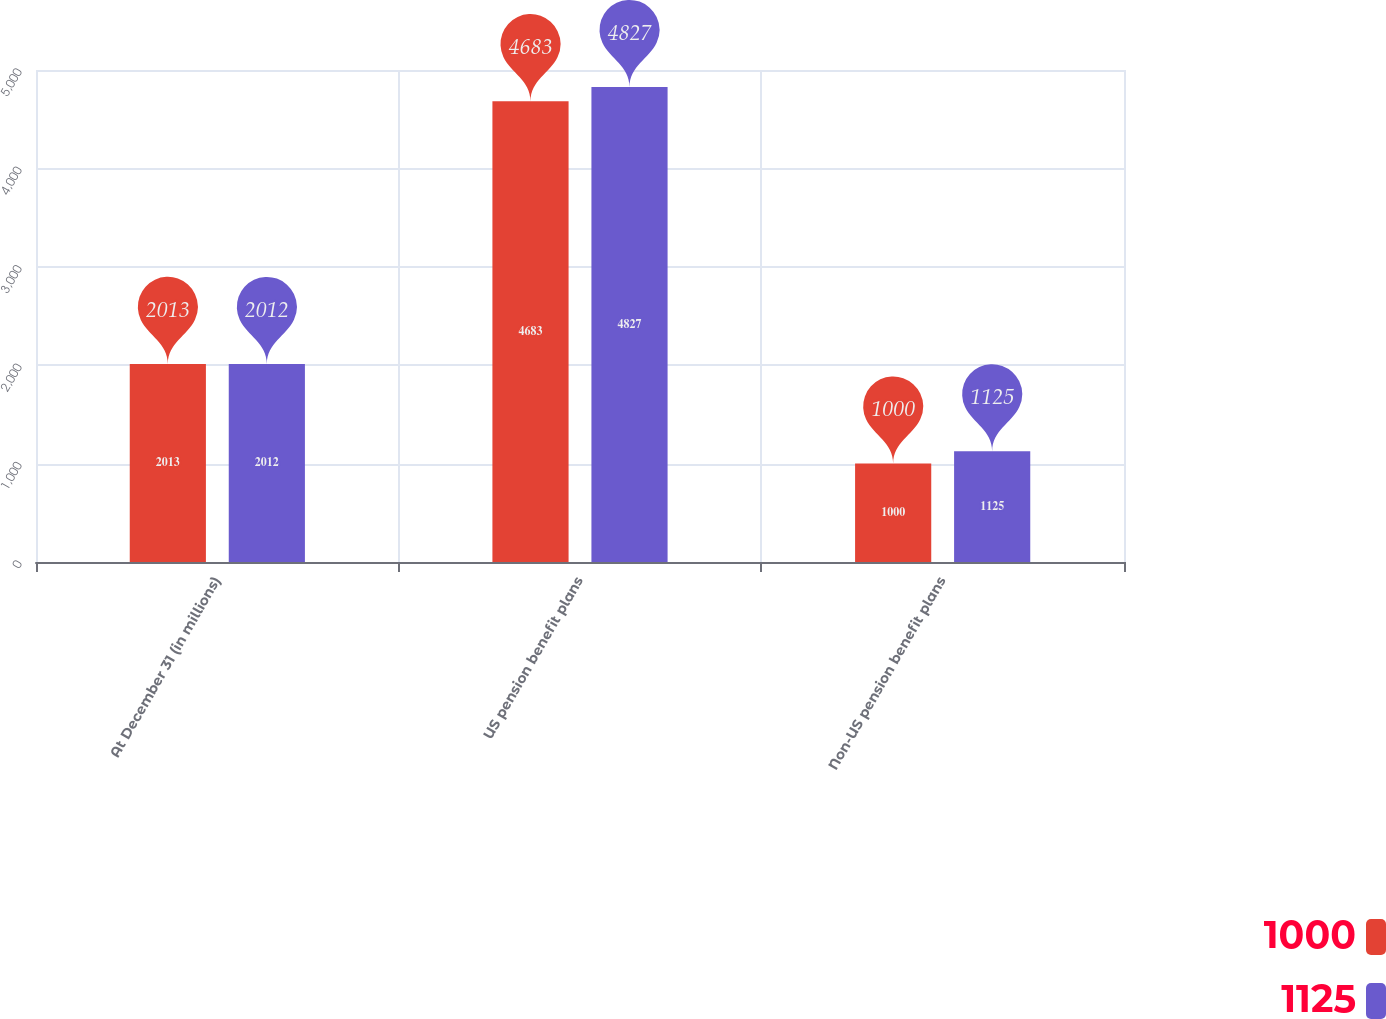Convert chart. <chart><loc_0><loc_0><loc_500><loc_500><stacked_bar_chart><ecel><fcel>At December 31 (in millions)<fcel>US pension benefit plans<fcel>Non-US pension benefit plans<nl><fcel>1000<fcel>2013<fcel>4683<fcel>1000<nl><fcel>1125<fcel>2012<fcel>4827<fcel>1125<nl></chart> 